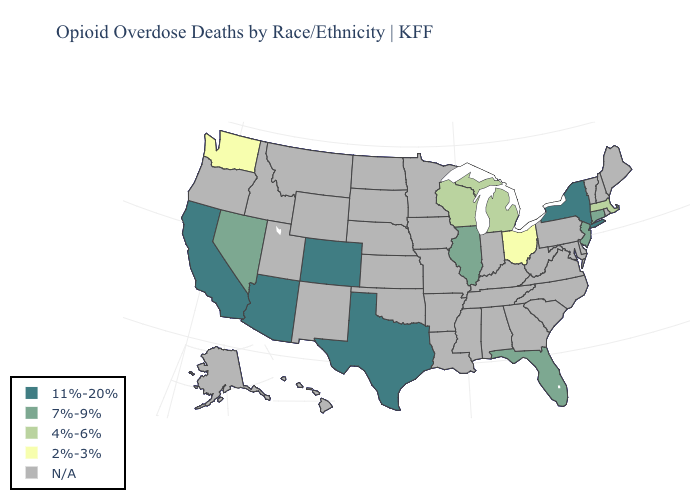What is the value of New York?
Quick response, please. 11%-20%. Name the states that have a value in the range 7%-9%?
Give a very brief answer. Connecticut, Florida, Illinois, Nevada, New Jersey. Which states have the highest value in the USA?
Be succinct. Arizona, California, Colorado, New York, Texas. Which states have the lowest value in the USA?
Answer briefly. Ohio, Washington. What is the value of Missouri?
Quick response, please. N/A. Name the states that have a value in the range N/A?
Be succinct. Alabama, Alaska, Arkansas, Delaware, Georgia, Hawaii, Idaho, Indiana, Iowa, Kansas, Kentucky, Louisiana, Maine, Maryland, Minnesota, Mississippi, Missouri, Montana, Nebraska, New Hampshire, New Mexico, North Carolina, North Dakota, Oklahoma, Oregon, Pennsylvania, Rhode Island, South Carolina, South Dakota, Tennessee, Utah, Vermont, Virginia, West Virginia, Wyoming. Does New York have the lowest value in the Northeast?
Quick response, please. No. Does Arizona have the highest value in the USA?
Write a very short answer. Yes. What is the highest value in the USA?
Answer briefly. 11%-20%. Name the states that have a value in the range N/A?
Quick response, please. Alabama, Alaska, Arkansas, Delaware, Georgia, Hawaii, Idaho, Indiana, Iowa, Kansas, Kentucky, Louisiana, Maine, Maryland, Minnesota, Mississippi, Missouri, Montana, Nebraska, New Hampshire, New Mexico, North Carolina, North Dakota, Oklahoma, Oregon, Pennsylvania, Rhode Island, South Carolina, South Dakota, Tennessee, Utah, Vermont, Virginia, West Virginia, Wyoming. Does the map have missing data?
Give a very brief answer. Yes. Does the first symbol in the legend represent the smallest category?
Quick response, please. No. What is the highest value in the West ?
Write a very short answer. 11%-20%. 